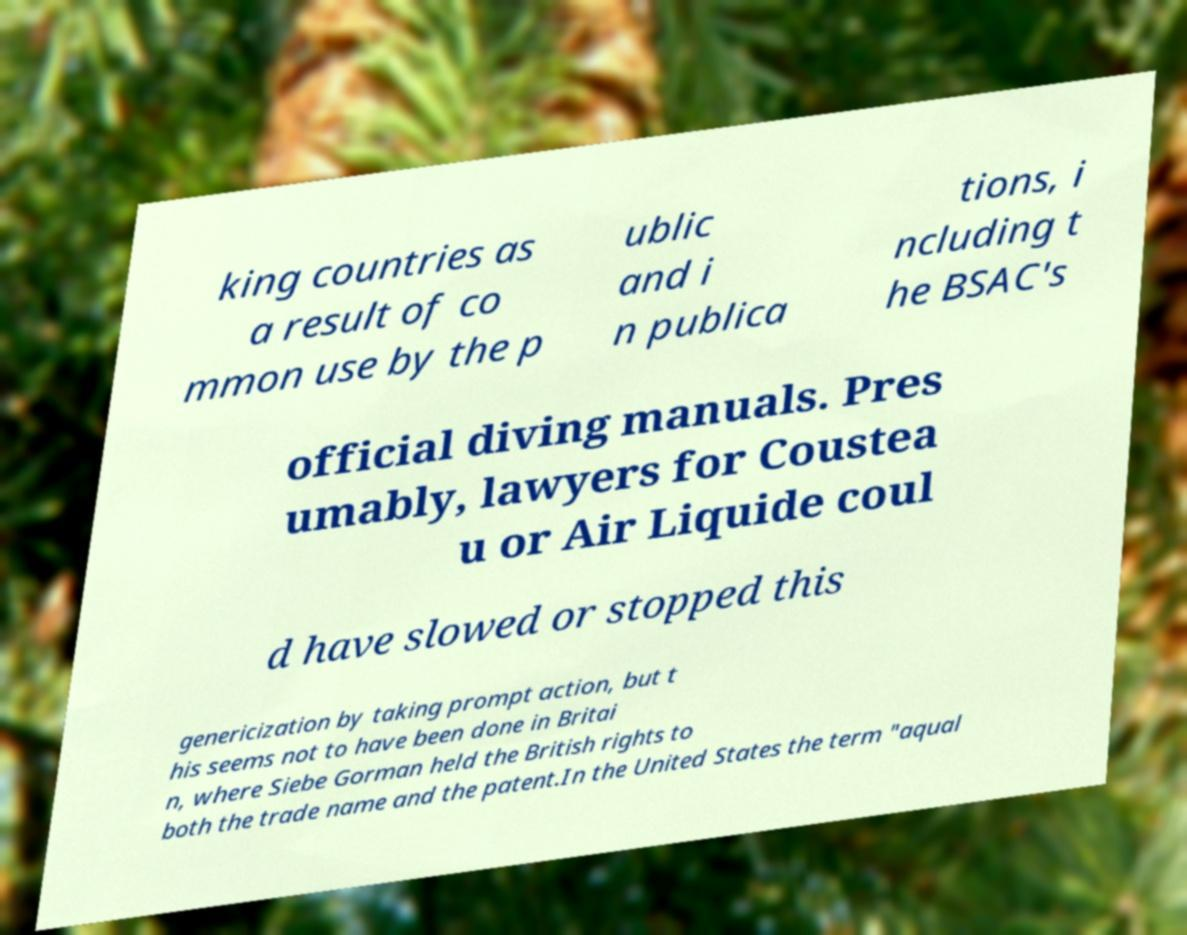For documentation purposes, I need the text within this image transcribed. Could you provide that? king countries as a result of co mmon use by the p ublic and i n publica tions, i ncluding t he BSAC's official diving manuals. Pres umably, lawyers for Coustea u or Air Liquide coul d have slowed or stopped this genericization by taking prompt action, but t his seems not to have been done in Britai n, where Siebe Gorman held the British rights to both the trade name and the patent.In the United States the term "aqual 